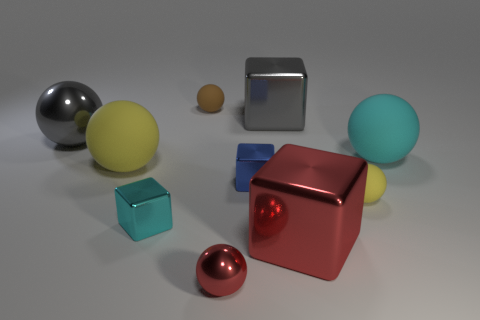Subtract all red balls. How many balls are left? 5 Subtract all cyan rubber balls. How many balls are left? 5 Subtract 2 balls. How many balls are left? 4 Subtract all blue spheres. Subtract all green blocks. How many spheres are left? 6 Subtract all balls. How many objects are left? 4 Subtract 2 yellow balls. How many objects are left? 8 Subtract all small gray objects. Subtract all small blue metal objects. How many objects are left? 9 Add 4 tiny yellow rubber things. How many tiny yellow rubber things are left? 5 Add 7 small purple matte cubes. How many small purple matte cubes exist? 7 